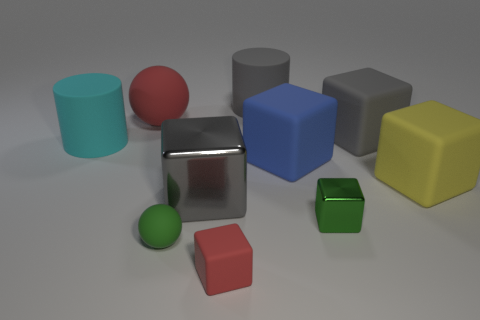Are the tiny green thing that is right of the tiny sphere and the blue thing made of the same material?
Provide a short and direct response. No. Are there fewer large yellow matte objects that are to the left of the green cube than green metal things?
Give a very brief answer. Yes. Is there a gray cylinder made of the same material as the small red thing?
Your response must be concise. Yes. Is the size of the gray metallic object the same as the rubber sphere that is to the right of the large red rubber object?
Provide a short and direct response. No. Is there a cylinder that has the same color as the big rubber sphere?
Your answer should be very brief. No. Is the green sphere made of the same material as the big red object?
Your answer should be very brief. Yes. There is a small green rubber ball; how many matte cubes are behind it?
Offer a terse response. 3. There is a gray object that is in front of the large sphere and to the right of the big metal cube; what is it made of?
Give a very brief answer. Rubber. What number of blocks are the same size as the green rubber object?
Give a very brief answer. 2. What is the color of the rubber cylinder to the right of the gray object that is in front of the blue block?
Provide a short and direct response. Gray. 